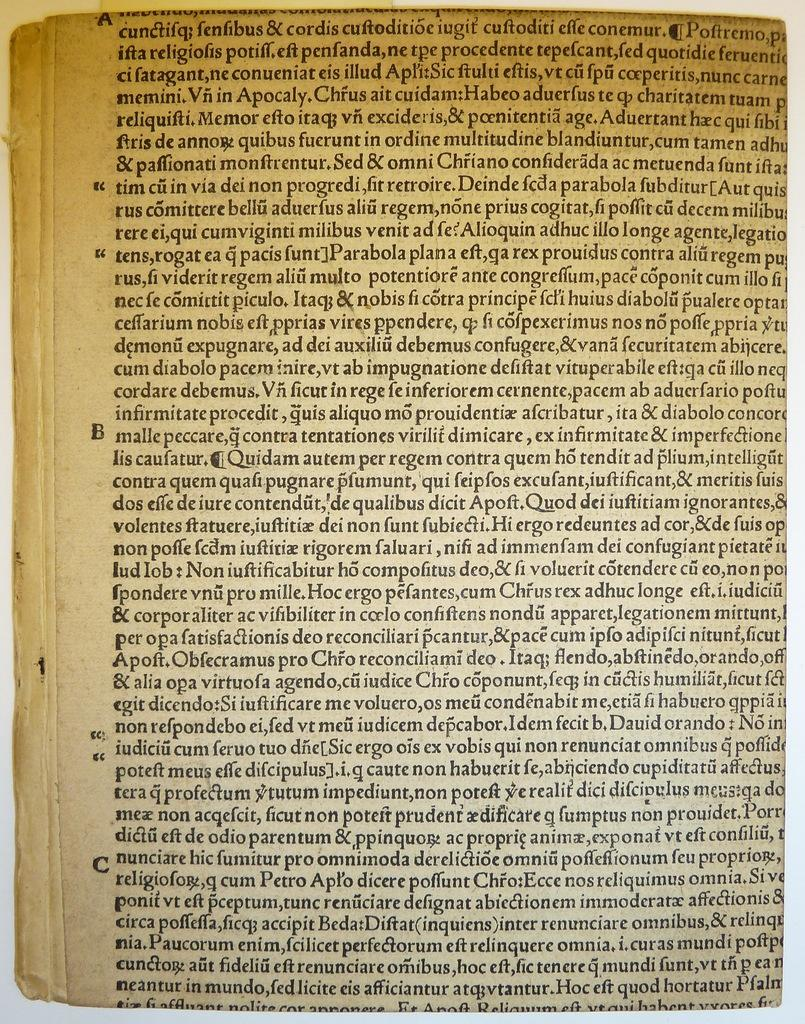<image>
Write a terse but informative summary of the picture. A page of a book with words such as Quidam and autem on it. 